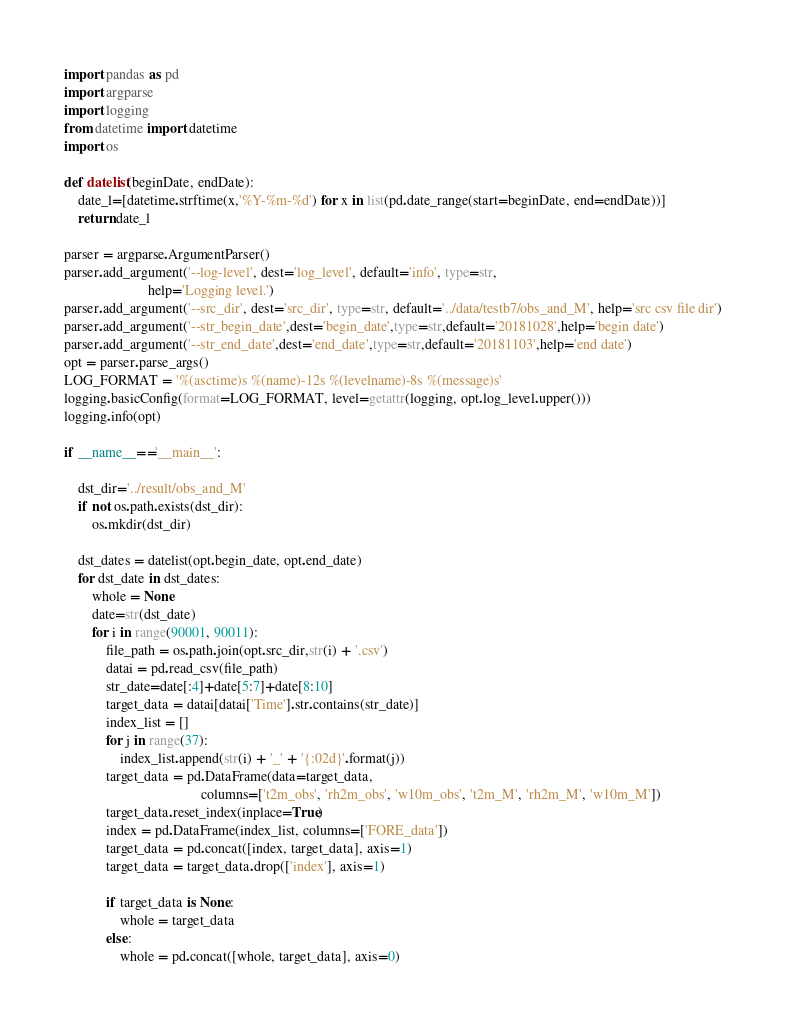Convert code to text. <code><loc_0><loc_0><loc_500><loc_500><_Python_>import pandas as pd
import argparse
import logging
from datetime import datetime
import os

def datelist(beginDate, endDate):
    date_l=[datetime.strftime(x,'%Y-%m-%d') for x in list(pd.date_range(start=beginDate, end=endDate))]
    return date_l

parser = argparse.ArgumentParser()
parser.add_argument('--log-level', dest='log_level', default='info', type=str,
                        help='Logging level.')
parser.add_argument('--src_dir', dest='src_dir', type=str, default='../data/testb7/obs_and_M', help='src csv file dir')
parser.add_argument('--str_begin_date',dest='begin_date',type=str,default='20181028',help='begin date')
parser.add_argument('--str_end_date',dest='end_date',type=str,default='20181103',help='end date')
opt = parser.parse_args()
LOG_FORMAT = '%(asctime)s %(name)-12s %(levelname)-8s %(message)s'
logging.basicConfig(format=LOG_FORMAT, level=getattr(logging, opt.log_level.upper()))
logging.info(opt)

if __name__=='__main__':

    dst_dir='../result/obs_and_M'
    if not os.path.exists(dst_dir):
        os.mkdir(dst_dir)

    dst_dates = datelist(opt.begin_date, opt.end_date)
    for dst_date in dst_dates:
        whole = None
        date=str(dst_date)
        for i in range(90001, 90011):
            file_path = os.path.join(opt.src_dir,str(i) + '.csv')
            datai = pd.read_csv(file_path)
            str_date=date[:4]+date[5:7]+date[8:10]
            target_data = datai[datai['Time'].str.contains(str_date)]
            index_list = []
            for j in range(37):
                index_list.append(str(i) + '_' + '{:02d}'.format(j))
            target_data = pd.DataFrame(data=target_data,
                                       columns=['t2m_obs', 'rh2m_obs', 'w10m_obs', 't2m_M', 'rh2m_M', 'w10m_M'])
            target_data.reset_index(inplace=True)
            index = pd.DataFrame(index_list, columns=['FORE_data'])
            target_data = pd.concat([index, target_data], axis=1)
            target_data = target_data.drop(['index'], axis=1)

            if target_data is None:
                whole = target_data
            else:
                whole = pd.concat([whole, target_data], axis=0)</code> 